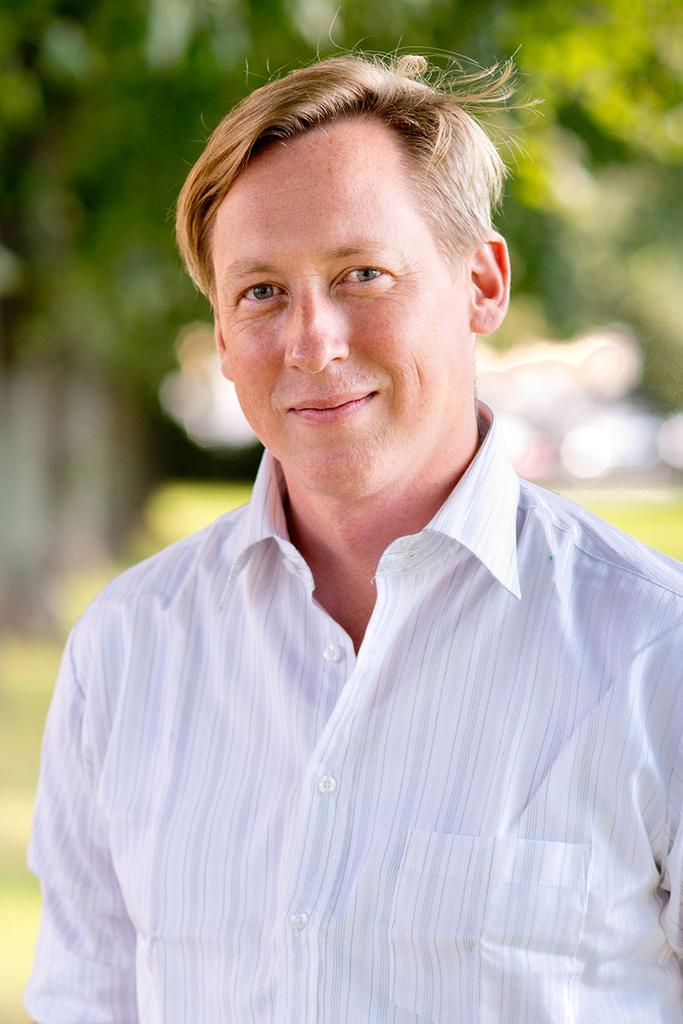What is present in the image? There is a man in the image. What is the man doing in the image? The man is smiling in the image. Can you describe the background of the image? The background of the image is blurred. What type of desire does the man have in the image? There is no indication of any specific desire in the image; it only shows the man smiling. Can you tell me how many parents are visible in the image? There are no parents present in the image; it only features a man smiling. 